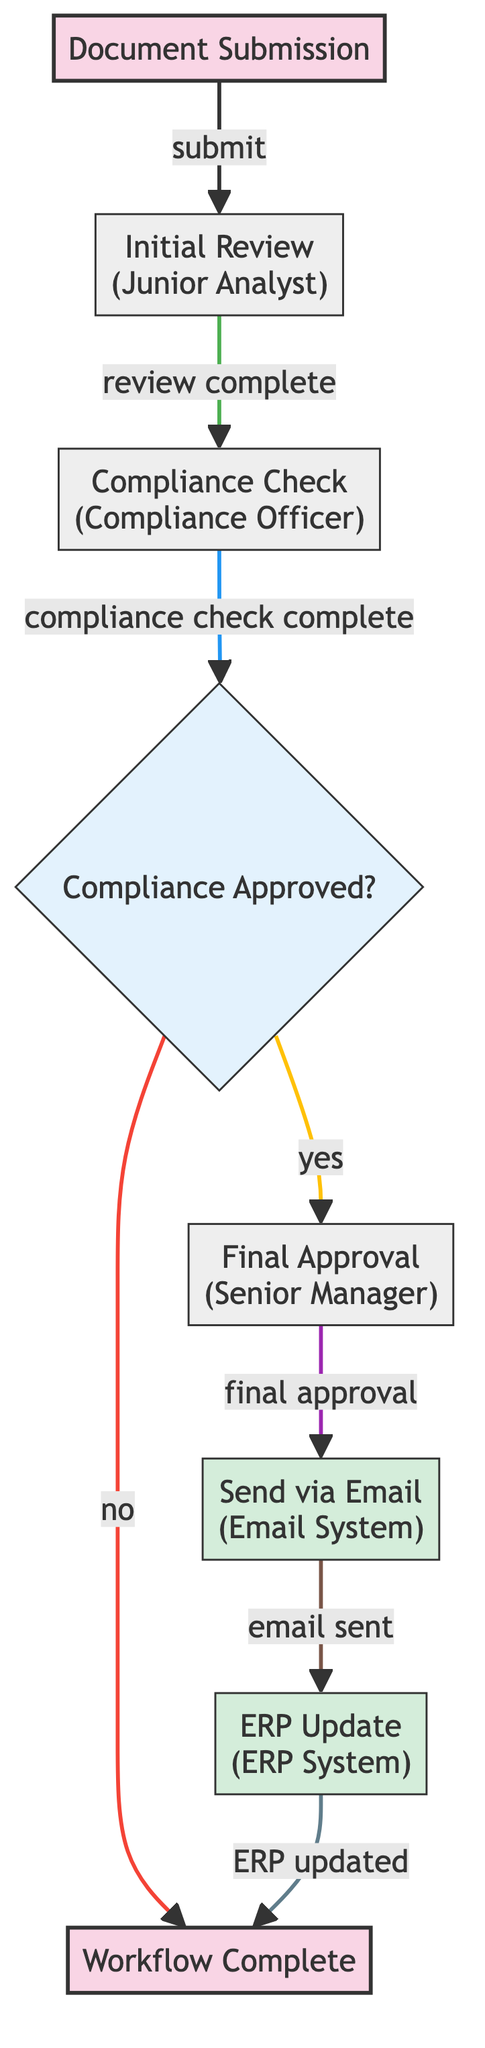What is the first step in the workflow? The workflow begins with the "Document Submission" node, which indicates that a user initiates the document workflow.
Answer: Document Submission How many tasks are there in the workflow? The diagram contains four tasks: "Initial Review," "Compliance Check," "Final Approval," and "Send via Email."
Answer: 4 Who is responsible for the "Compliance Check"? The "Compliance Check" task is assigned to the "Compliance Officer," as indicated in the task node description.
Answer: Compliance Officer What happens if the document is not compliant? If the document is not compliant, the workflow ends at the "Workflow Complete" node, as indicated by the "no" decision path from the "Compliance Approved?" decision node.
Answer: Workflow Complete What is the integration point for sending emails? The integration point for sending emails is the "Email System," which is mentioned in the description of the "Send via Email" task node.
Answer: Email System Which node comes after the "Final Approval"? Following the "Final Approval," the next node is "Send via Email," according to the directional flow from the final approval task.
Answer: Send via Email How many edges lead out from the "Compliance Approved?" decision node? There are two edges leading out from the "Compliance Approved?" decision node: one for "yes" which leads to "Final Approval," and another for "no" which leads to "Workflow Complete."
Answer: 2 What task is conducted by the "Junior Analyst"? The task assigned to the "Junior Analyst" is the "Initial Review," where the analyst conducts the review of the document.
Answer: Initial Review What does the "ERP Update" task do? The "ERP Update" task updates the document status in the ERP system, as detailed in its description.
Answer: Update document status in ERP system What is the purpose of the "Compliance Check"? The purpose of the "Compliance Check" task is to check the document for compliance, which is necessary before moving forward in the workflow.
Answer: Check document for compliance 